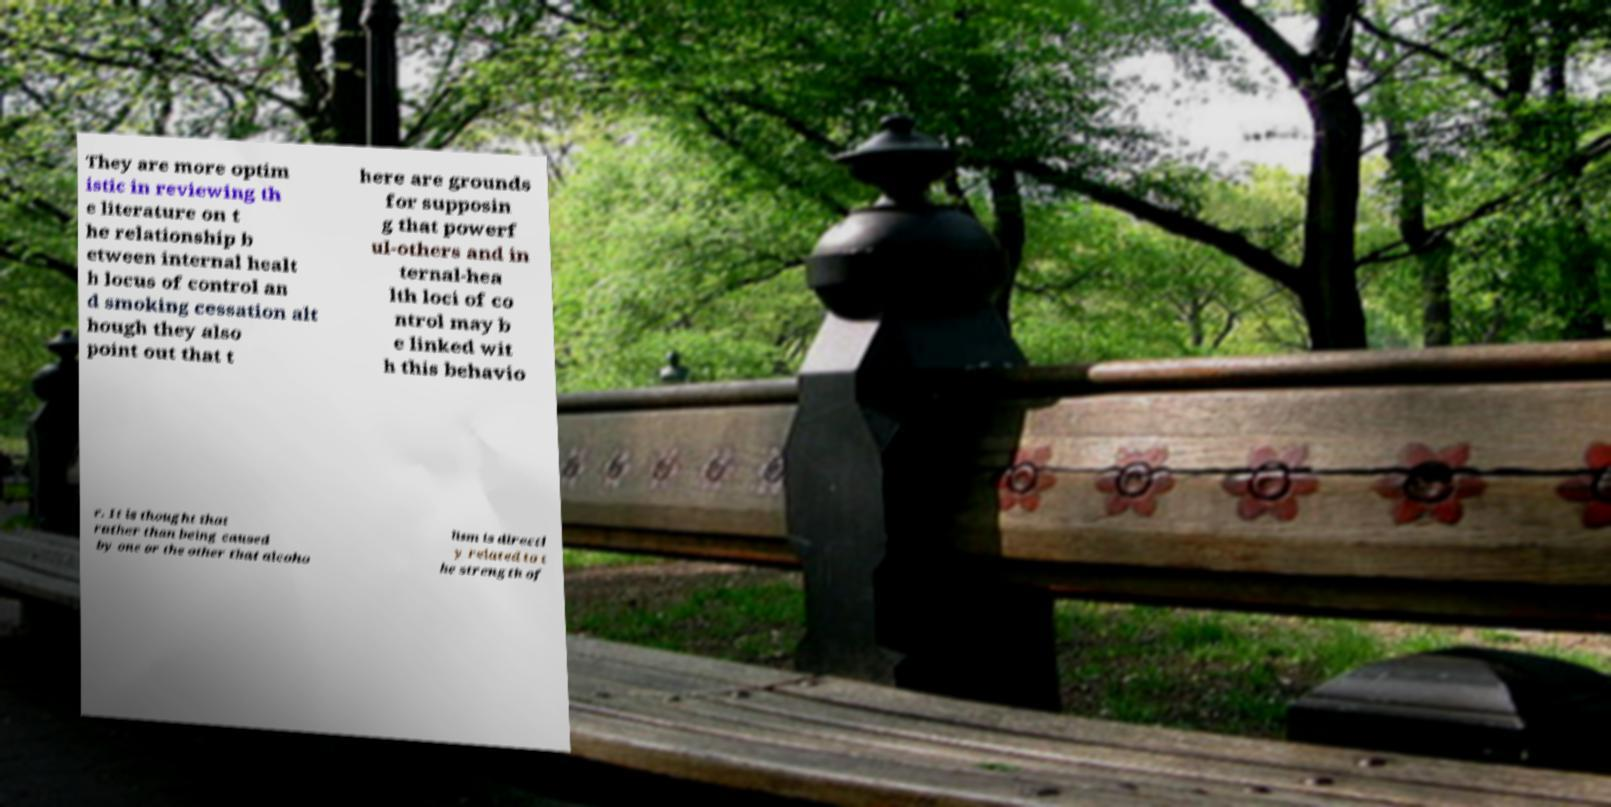I need the written content from this picture converted into text. Can you do that? They are more optim istic in reviewing th e literature on t he relationship b etween internal healt h locus of control an d smoking cessation alt hough they also point out that t here are grounds for supposin g that powerf ul-others and in ternal-hea lth loci of co ntrol may b e linked wit h this behavio r. It is thought that rather than being caused by one or the other that alcoho lism is directl y related to t he strength of 